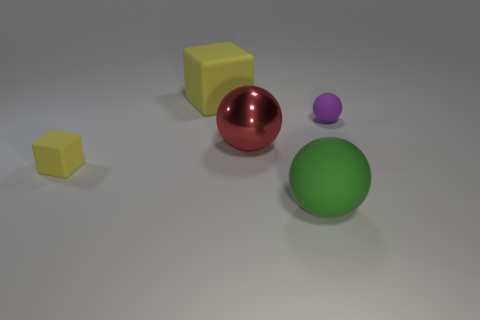There is a tiny thing that is behind the metal thing; does it have the same color as the large rubber thing that is to the right of the red thing?
Ensure brevity in your answer.  No. There is a thing that is both in front of the red sphere and right of the big red shiny thing; what color is it?
Provide a succinct answer. Green. Do the small purple object and the tiny yellow object have the same material?
Your answer should be compact. Yes. How many big things are purple things or purple matte cubes?
Your answer should be compact. 0. Are there any other things that are the same shape as the red shiny object?
Provide a succinct answer. Yes. Is there any other thing that has the same size as the green rubber sphere?
Offer a very short reply. Yes. There is a tiny cube that is made of the same material as the purple object; what color is it?
Your answer should be compact. Yellow. There is a rubber object that is in front of the tiny yellow object; what color is it?
Your answer should be compact. Green. How many shiny balls have the same color as the tiny cube?
Offer a very short reply. 0. Are there fewer matte things behind the tiny yellow matte cube than tiny purple matte things that are to the right of the large yellow block?
Provide a succinct answer. No. 